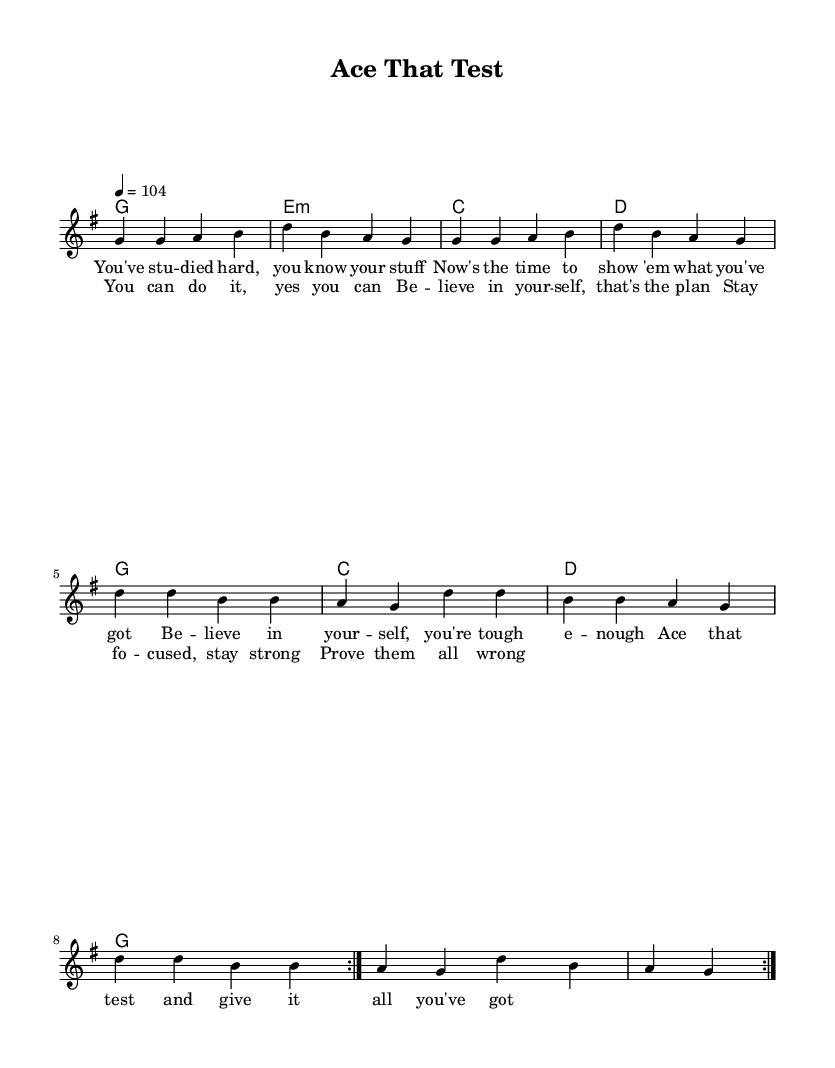What is the key signature of this music? The key signature is G major, which has one sharp (F#).
Answer: G major What is the time signature of this music? The time signature is 4/4, indicating four beats per measure.
Answer: 4/4 What is the tempo marking in this piece? The tempo marking is 104 beats per minute, indicating a moderate pace for the performance.
Answer: 104 How many times does the melody repeat in the first section? The melody repeats two times, as indicated by the "repeat volta 2" directive.
Answer: 2 What are the first four notes of the melody? The first four notes of the melody are G, G, A, and B, starting off the phrase energetically.
Answer: G, G, A, B Identify the emotion conveyed by the lyrics in this song. The lyrics exhibit motivation and confidence, encouraging the performer to believe in themselves and succeed.
Answer: Motivation What is the chord progression used in the refrain? The chord progression in the refrain consists of G, E minor, C, and D, followed by G, C, D, and G again.
Answer: G, E minor, C, D 